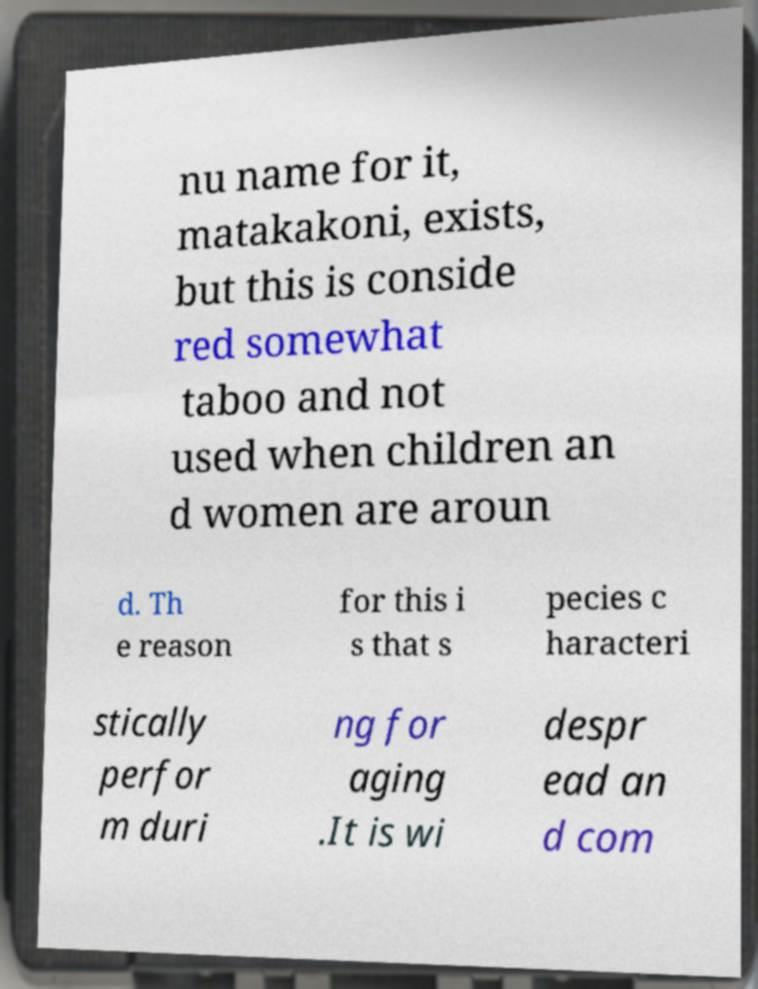What messages or text are displayed in this image? I need them in a readable, typed format. nu name for it, matakakoni, exists, but this is conside red somewhat taboo and not used when children an d women are aroun d. Th e reason for this i s that s pecies c haracteri stically perfor m duri ng for aging .It is wi despr ead an d com 